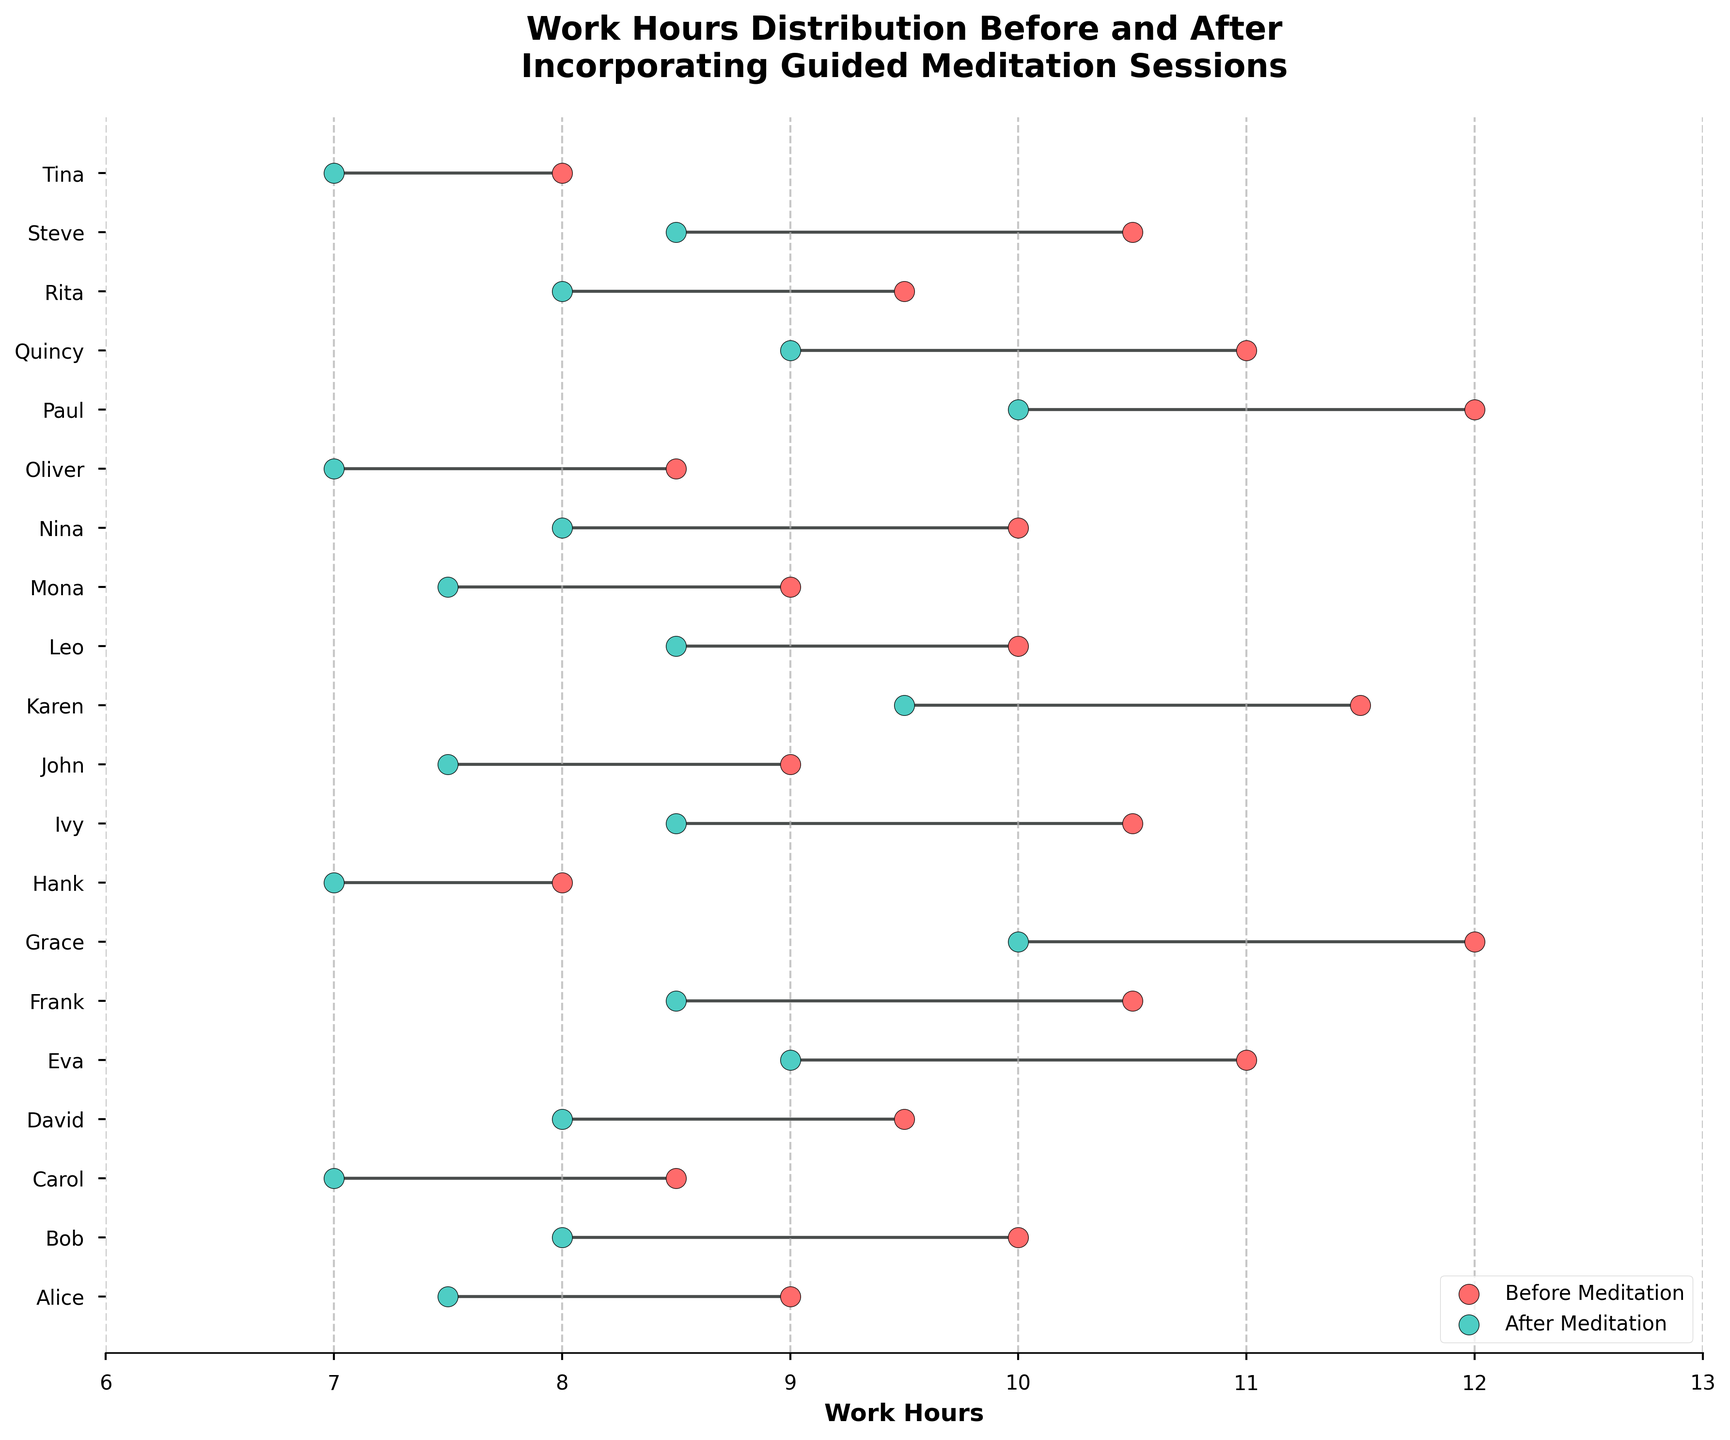What is the title of the plot? The title of the plot is displayed prominently at the top and reads "Work Hours Distribution Before and After Incorporating Guided Meditation Sessions".
Answer: Work Hours Distribution Before and After Incorporating Guided Meditation Sessions What color represents work hours before incorporating guided meditation sessions? The figure uses red (with an edge of black) to represent work hours before incorporating guided meditation sessions according to the legend on the plot.
Answer: Red How many remote workers are represented in the plot? Each remote worker is represented by a different row on the y-axis. Counting the labels, there are 20 remote workers shown on the plot.
Answer: 20 Who reduced their work hours the most after incorporating guided meditation sessions? The worker with the largest reduction in work hours will have the longest line between the two points. Grace reduced from 12 to 10 hours, hence an overall reduction of 2 hours.
Answer: Grace What is the average work hours reduction for all remote workers after incorporating guided meditation sessions? To calculate the average work hours reduction, subtract each worker's 'work_hours_after' from 'work_hours_before', sum up these differences and then divide by the total number of workers. The average reduction is \( \frac{(9-7.5) + (10-8) + (8.5-7) + (9.5-8) + (11-9) + (10.5-8.5) + (12-10) + (8-7) + (10.5-8.5) + (9-7.5) + (11.5-9.5) + (10-8.5) + (9-7.5) + (10-8) + (8.5-7) + (12-10) + (11-9) + (9.5-8) + (10.5-8.5) + (8-7)} {20} = 2 \)
Answer: 2 hours What is the range of work hours before incorporating guided meditation sessions? To find the range, subtract the minimum value from the maximum value of 'work_hours_before'. The range is \(12 - 8 = 4\).
Answer: 4 hours Which remote worker has the smallest change in work hours after incorporating guided meditation sessions? The smallest change will be the shortest line between the two data points on the same row. Several workers (Bob, David, Frank, Ivy, Leo, Steve) each have a reduction of 1.5 hours, the smallest in the dataset.
Answer: Multiple workers (Bob, David, Frank, Ivy, Leo, Steve) What color represents work hours after incorporating guided meditation sessions? According to the legend on the plot, the color used for work hours after incorporating guided meditation sessions is green (with the edge of black).
Answer: Green Which worker had the highest work hours before guided meditation sessions, and what were those hours? By looking at the y-axis labels and the corresponding points, Grace had the highest work hours before guided meditation at 12 hours.
Answer: Grace, 12 hours Which worker had the lowest work hours after guided meditation sessions, and what were those hours? Referring to the green dots and matching them to the y-axis label, both Carol and Oliver have the lowest work hours after guided meditation sessions, which is 7 hours.
Answer: Carol, Oliver, 7 hours 